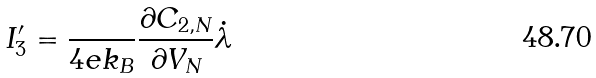<formula> <loc_0><loc_0><loc_500><loc_500>I _ { 3 } ^ { \prime } = \frac { } { 4 e k _ { B } } \frac { \partial C _ { 2 , N } } { \partial V _ { N } } \dot { \lambda } \,</formula> 